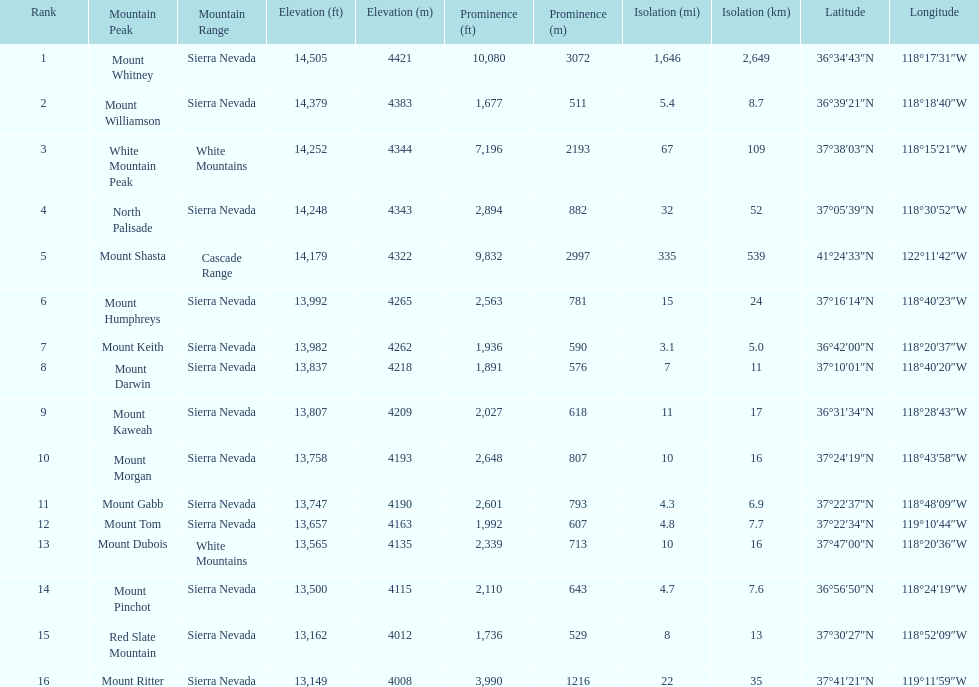I'm looking to parse the entire table for insights. Could you assist me with that? {'header': ['Rank', 'Mountain Peak', 'Mountain Range', 'Elevation (ft)', 'Elevation (m)', 'Prominence (ft)', 'Prominence (m)', 'Isolation (mi)', 'Isolation (km)', 'Latitude', 'Longitude'], 'rows': [['1', 'Mount Whitney', 'Sierra Nevada', '14,505', '4421', '10,080', '3072', '1,646', '2,649', '36°34′43″N', '118°17′31″W'], ['2', 'Mount Williamson', 'Sierra Nevada', '14,379', '4383', '1,677', '511', '5.4', '8.7', '36°39′21″N', '118°18′40″W'], ['3', 'White Mountain Peak', 'White Mountains', '14,252', '4344', '7,196', '2193', '67', '109', '37°38′03″N', '118°15′21″W'], ['4', 'North Palisade', 'Sierra Nevada', '14,248', '4343', '2,894', '882', '32', '52', '37°05′39″N', '118°30′52″W'], ['5', 'Mount Shasta', 'Cascade Range', '14,179', '4322', '9,832', '2997', '335', '539', '41°24′33″N', '122°11′42″W'], ['6', 'Mount Humphreys', 'Sierra Nevada', '13,992', '4265', '2,563', '781', '15', '24', '37°16′14″N', '118°40′23″W'], ['7', 'Mount Keith', 'Sierra Nevada', '13,982', '4262', '1,936', '590', '3.1', '5.0', '36°42′00″N', '118°20′37″W'], ['8', 'Mount Darwin', 'Sierra Nevada', '13,837', '4218', '1,891', '576', '7', '11', '37°10′01″N', '118°40′20″W'], ['9', 'Mount Kaweah', 'Sierra Nevada', '13,807', '4209', '2,027', '618', '11', '17', '36°31′34″N', '118°28′43″W'], ['10', 'Mount Morgan', 'Sierra Nevada', '13,758', '4193', '2,648', '807', '10', '16', '37°24′19″N', '118°43′58″W'], ['11', 'Mount Gabb', 'Sierra Nevada', '13,747', '4190', '2,601', '793', '4.3', '6.9', '37°22′37″N', '118°48′09″W'], ['12', 'Mount Tom', 'Sierra Nevada', '13,657', '4163', '1,992', '607', '4.8', '7.7', '37°22′34″N', '119°10′44″W'], ['13', 'Mount Dubois', 'White Mountains', '13,565', '4135', '2,339', '713', '10', '16', '37°47′00″N', '118°20′36″W'], ['14', 'Mount Pinchot', 'Sierra Nevada', '13,500', '4115', '2,110', '643', '4.7', '7.6', '36°56′50″N', '118°24′19″W'], ['15', 'Red Slate Mountain', 'Sierra Nevada', '13,162', '4012', '1,736', '529', '8', '13', '37°30′27″N', '118°52′09″W'], ['16', 'Mount Ritter', 'Sierra Nevada', '13,149', '4008', '3,990', '1216', '22', '35', '37°41′21″N', '119°11′59″W']]} Which mountain peak has the least isolation? Mount Keith. 